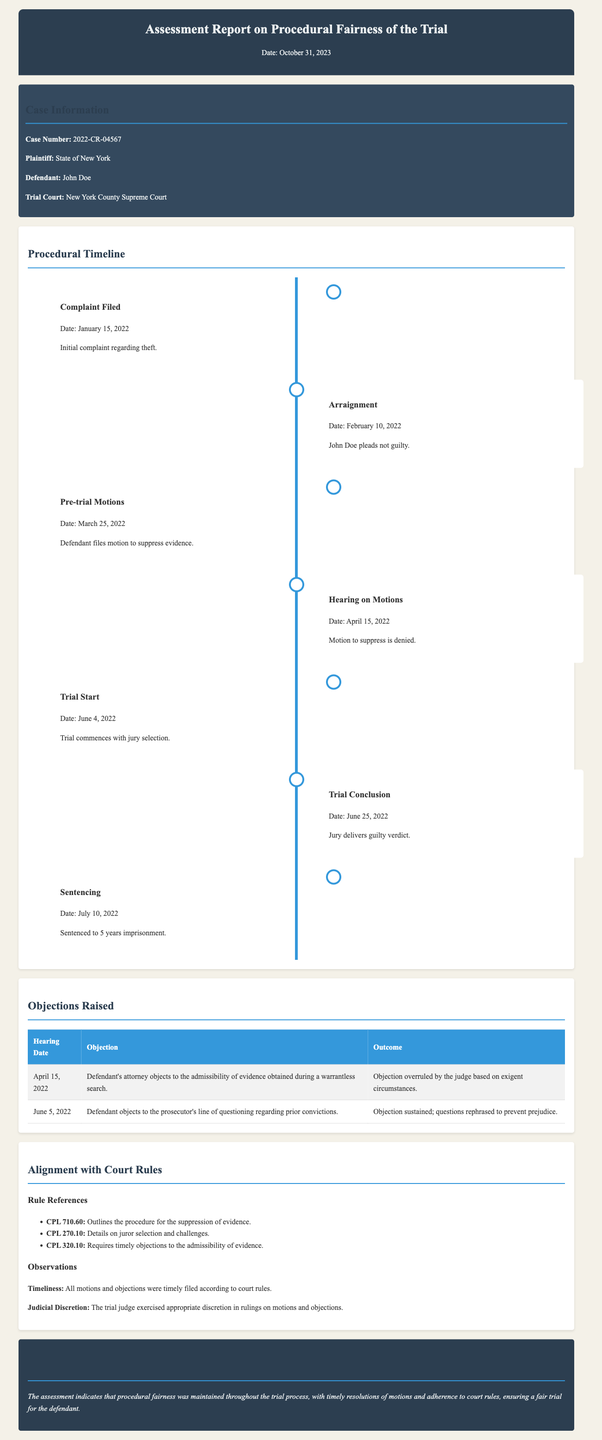what is the case number? The case number is mentioned in the case information section of the document.
Answer: 2022-CR-04567 what was the date of the arraignment? The arraignment date is specified in the procedural timeline.
Answer: February 10, 2022 what was the outcome of the motion to suppress evidence? The outcome of the motion is found in the procedural timeline, specifically the hearing on motions.
Answer: Denied how many years was the defendant sentenced to? The sentencing details are located in the procedural timeline.
Answer: 5 years what objection was raised on April 15, 2022? The objection details can be found in the table of objections raised.
Answer: Admissibility of evidence obtained during a warrantless search which rule covers the procedure for suppression of evidence? The relevant rule is listed in the alignment with court rules section of the document.
Answer: CPL 710.60 what is stated about the timeliness of motions and objections? The observations section discusses the timeliness of motions and objections.
Answer: Timely filed what is the conclusion of the assessment report? The conclusion summarizing the assessment is available at the end of the document.
Answer: Procedural fairness was maintained 